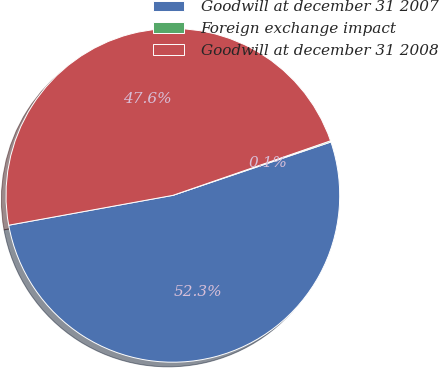Convert chart to OTSL. <chart><loc_0><loc_0><loc_500><loc_500><pie_chart><fcel>Goodwill at december 31 2007<fcel>Foreign exchange impact<fcel>Goodwill at december 31 2008<nl><fcel>52.32%<fcel>0.12%<fcel>47.56%<nl></chart> 